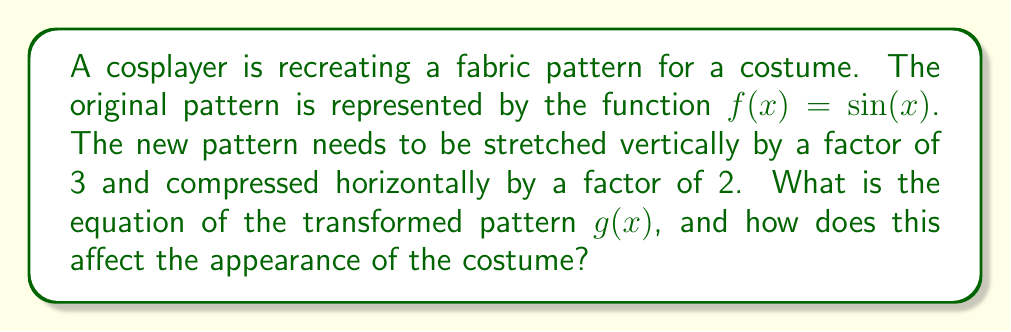Give your solution to this math problem. To solve this problem, we need to apply vertical and horizontal transformations to the original function $f(x) = \sin(x)$.

1. Vertical stretch:
   The pattern is stretched vertically by a factor of 3. This means we multiply the function by 3:
   $3\sin(x)$

2. Horizontal compression:
   The pattern is compressed horizontally by a factor of 2. This means we multiply the input $x$ by 2:
   $3\sin(2x)$

Therefore, the transformed function $g(x)$ is:

$g(x) = 3\sin(2x)$

Effect on the costume's appearance:
- Vertical stretch: The amplitude of the sine wave is tripled, making the pattern appear taller or more exaggerated vertically. This could result in more dramatic curves or folds in the fabric.
- Horizontal compression: The period of the sine wave is halved, making the pattern repeat twice as often along the horizontal axis. This will create a denser, more compact pattern horizontally.

For a cosplayer, these transformations would result in a more dramatic and intricate fabric pattern. The costume would have more pronounced vertical features and a higher frequency of pattern repetition horizontally, potentially creating a more detailed and eye-catching design.
Answer: $g(x) = 3\sin(2x)$ 